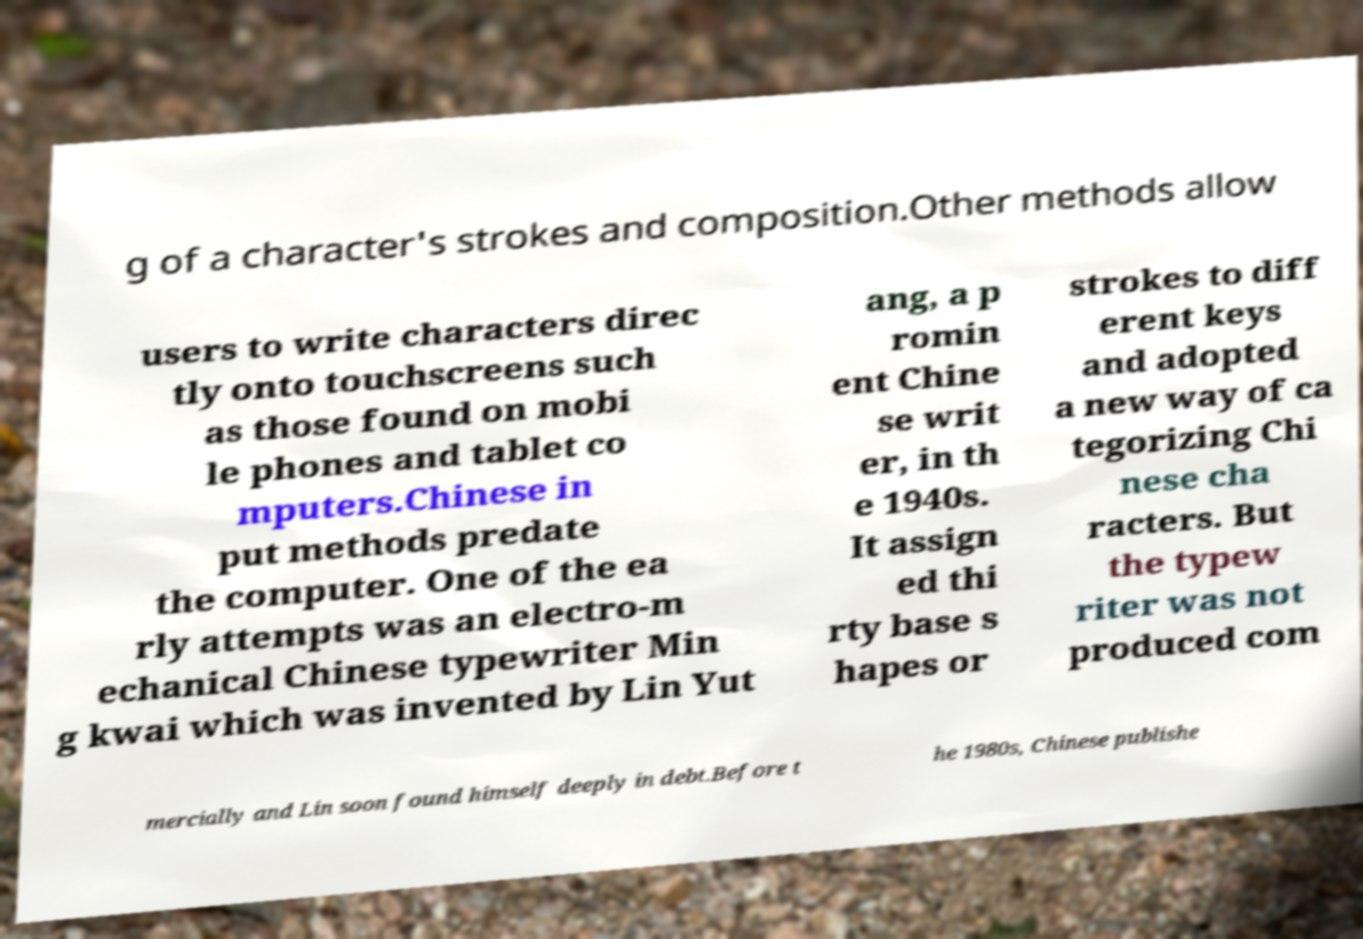Can you accurately transcribe the text from the provided image for me? g of a character's strokes and composition.Other methods allow users to write characters direc tly onto touchscreens such as those found on mobi le phones and tablet co mputers.Chinese in put methods predate the computer. One of the ea rly attempts was an electro-m echanical Chinese typewriter Min g kwai which was invented by Lin Yut ang, a p romin ent Chine se writ er, in th e 1940s. It assign ed thi rty base s hapes or strokes to diff erent keys and adopted a new way of ca tegorizing Chi nese cha racters. But the typew riter was not produced com mercially and Lin soon found himself deeply in debt.Before t he 1980s, Chinese publishe 